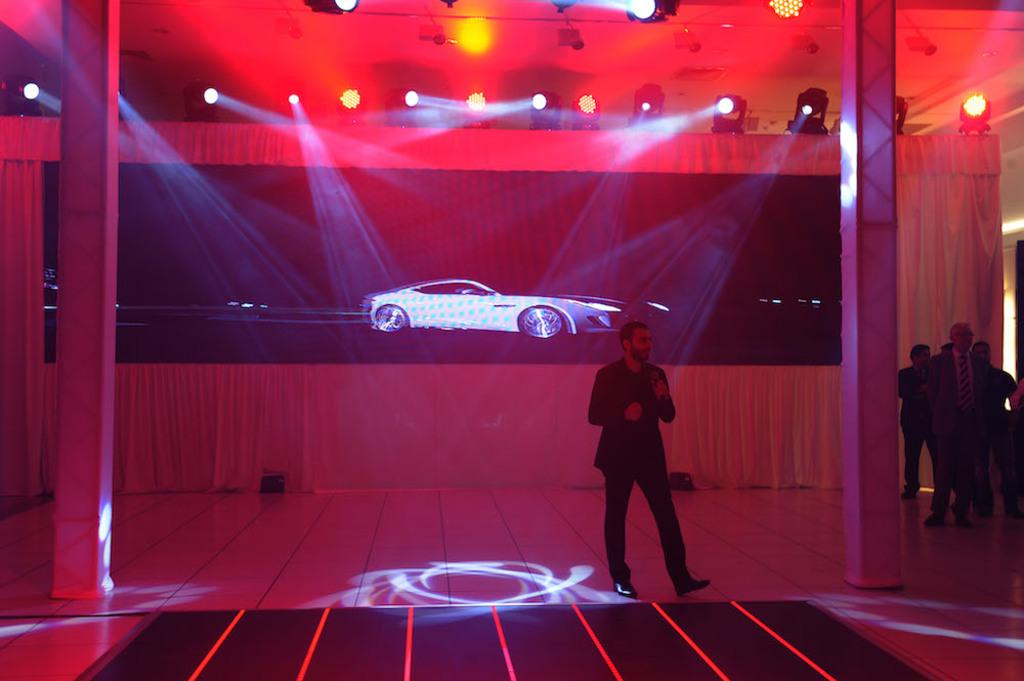What is the person in the image holding? The person in the image is holding a microphone. Are there other people present in the image? Yes, there are other people standing in the image. What type of lighting is visible in the image? Focus lights are visible in the image. What type of covering is present in the image? There are curtains in the image. What type of display device is present in the image? There is a screen in the image. What color is the crayon being used by the person holding the microphone in the image? There is no crayon present in the image; the person is holding a microphone. 